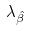<formula> <loc_0><loc_0><loc_500><loc_500>\lambda _ { \hat { \beta } }</formula> 